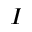Convert formula to latex. <formula><loc_0><loc_0><loc_500><loc_500>I</formula> 